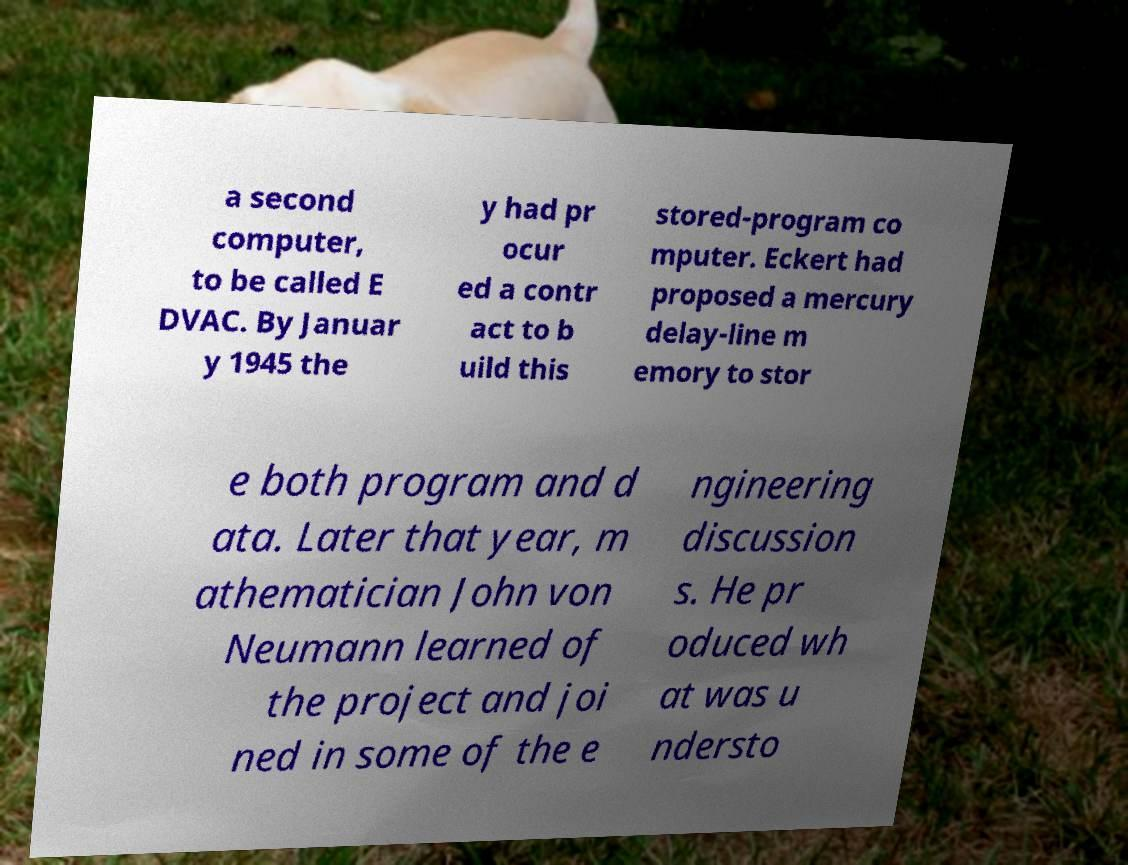Please read and relay the text visible in this image. What does it say? a second computer, to be called E DVAC. By Januar y 1945 the y had pr ocur ed a contr act to b uild this stored-program co mputer. Eckert had proposed a mercury delay-line m emory to stor e both program and d ata. Later that year, m athematician John von Neumann learned of the project and joi ned in some of the e ngineering discussion s. He pr oduced wh at was u ndersto 